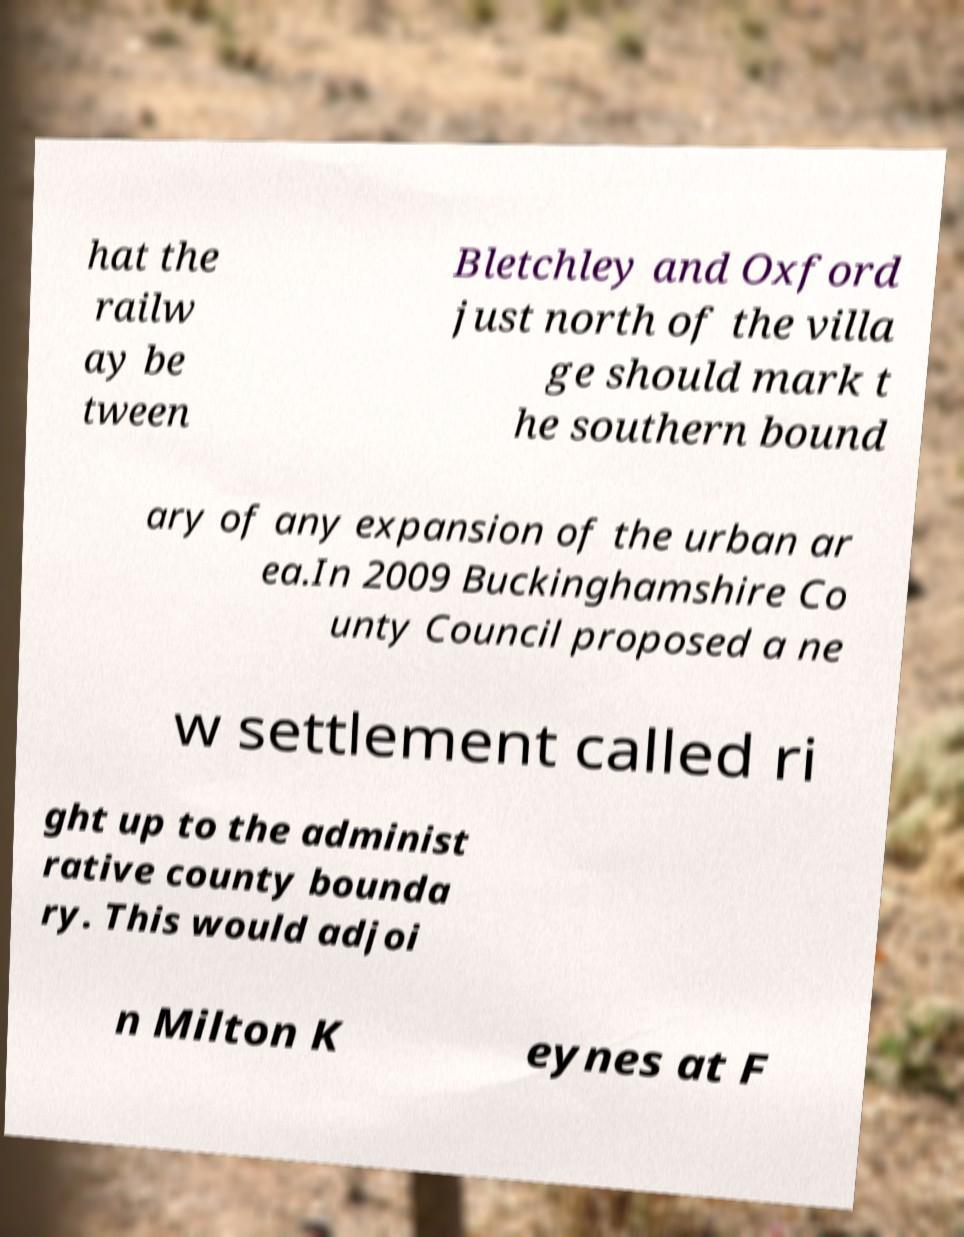Could you extract and type out the text from this image? hat the railw ay be tween Bletchley and Oxford just north of the villa ge should mark t he southern bound ary of any expansion of the urban ar ea.In 2009 Buckinghamshire Co unty Council proposed a ne w settlement called ri ght up to the administ rative county bounda ry. This would adjoi n Milton K eynes at F 